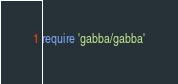Convert code to text. <code><loc_0><loc_0><loc_500><loc_500><_Ruby_>require 'gabba/gabba'
</code> 